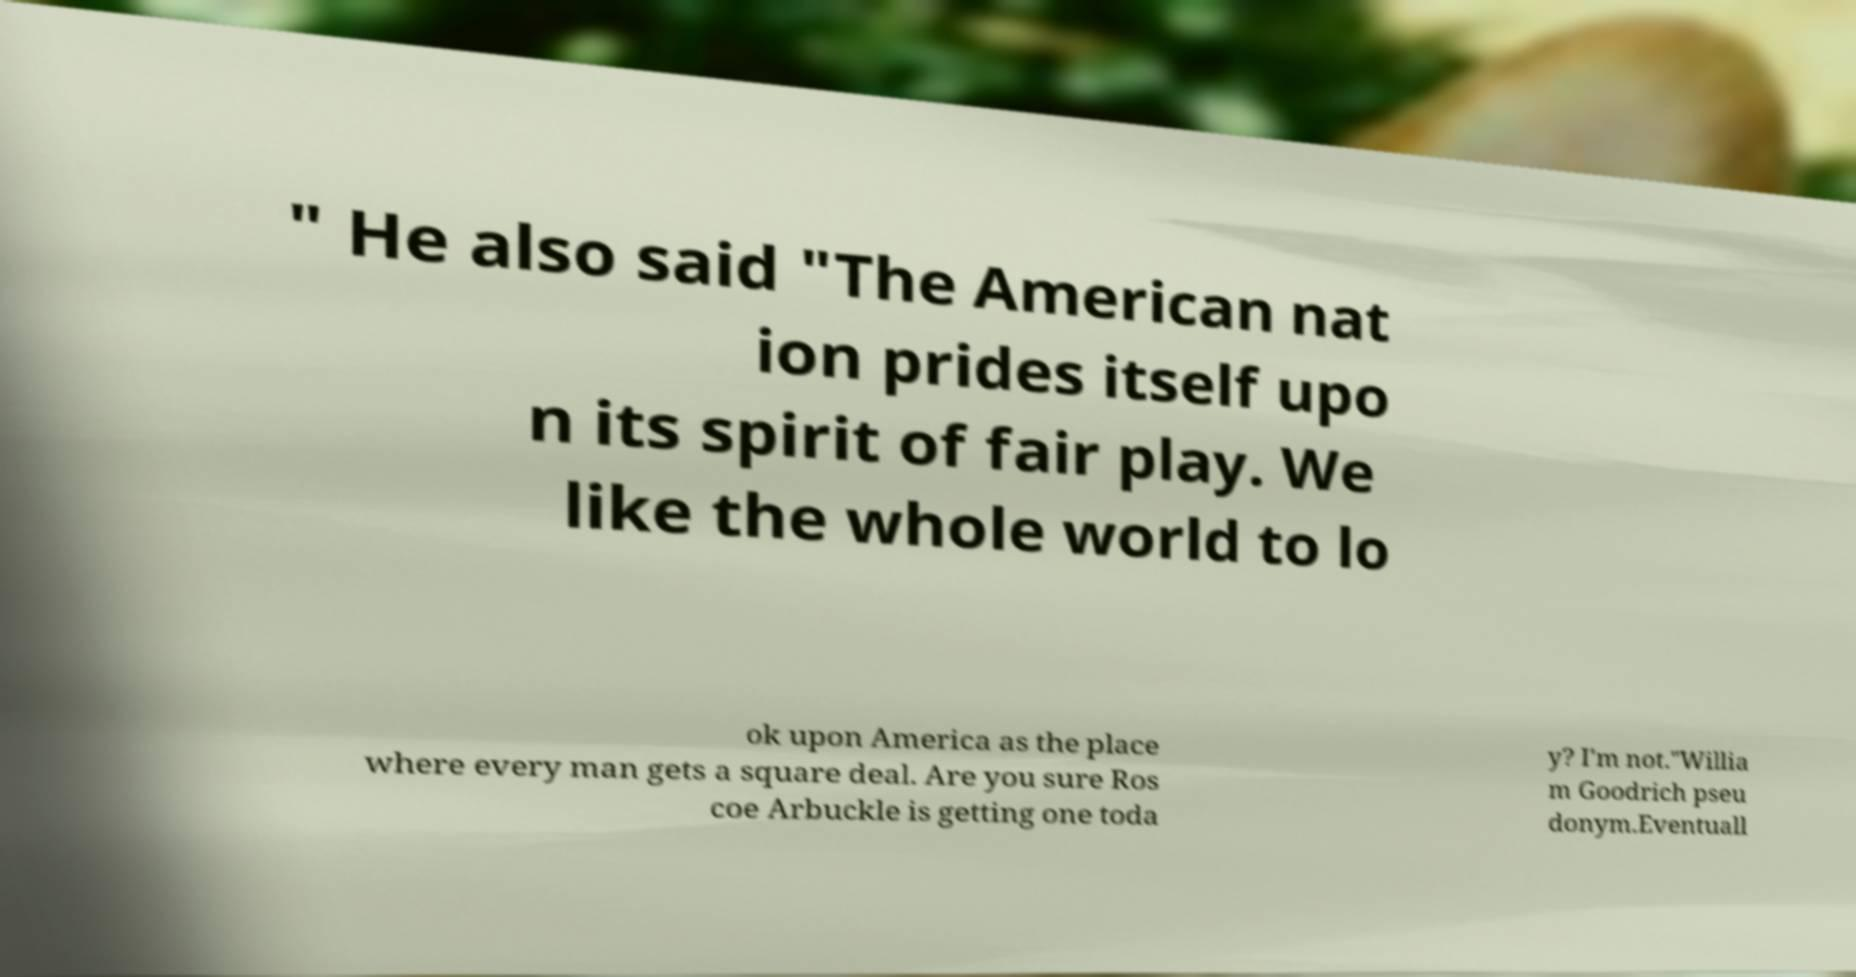What messages or text are displayed in this image? I need them in a readable, typed format. " He also said "The American nat ion prides itself upo n its spirit of fair play. We like the whole world to lo ok upon America as the place where every man gets a square deal. Are you sure Ros coe Arbuckle is getting one toda y? I'm not."Willia m Goodrich pseu donym.Eventuall 